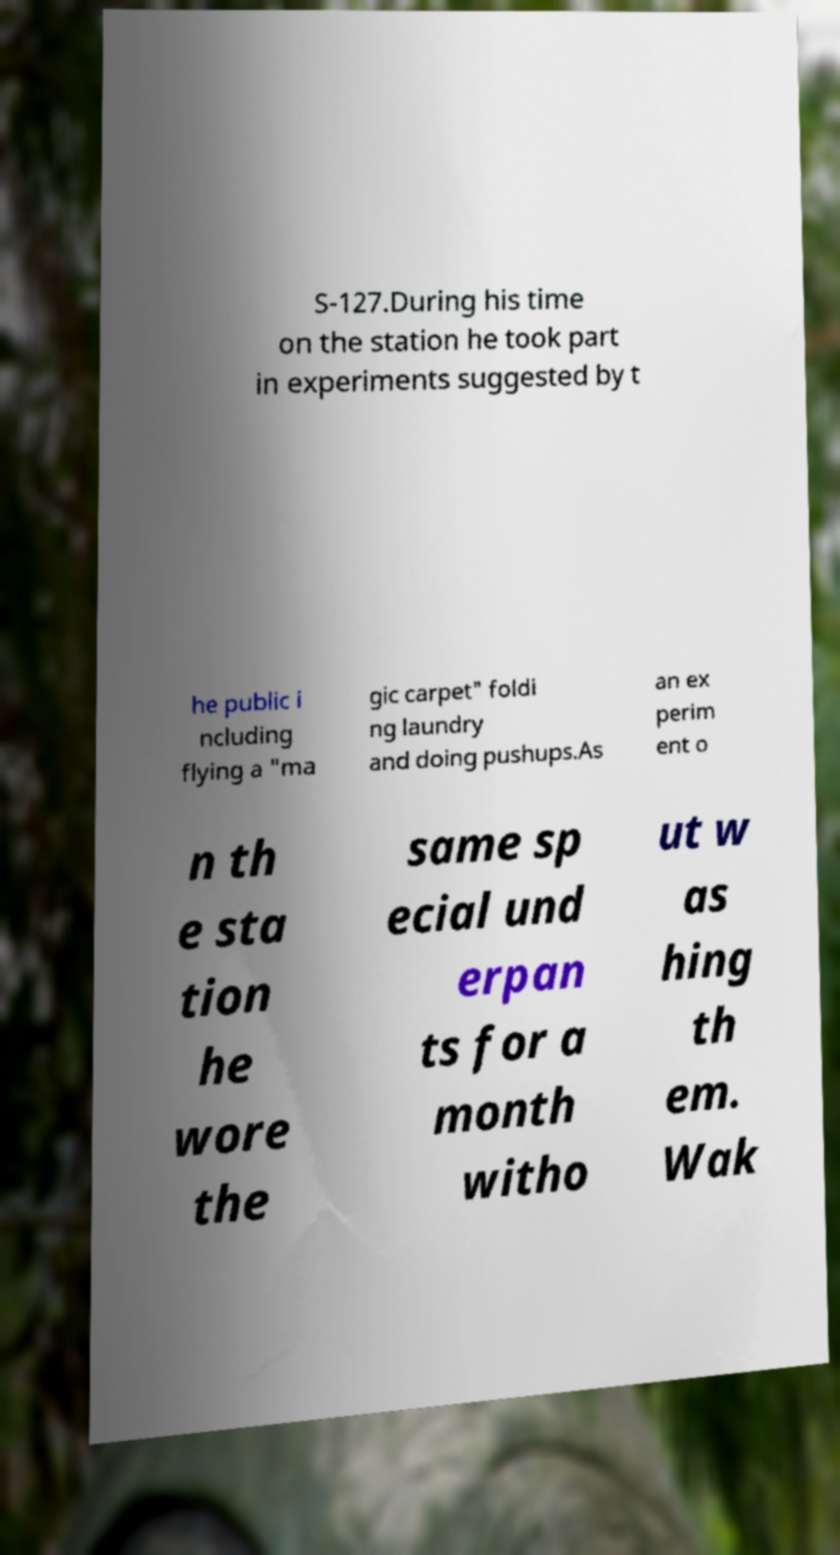Can you read and provide the text displayed in the image?This photo seems to have some interesting text. Can you extract and type it out for me? S-127.During his time on the station he took part in experiments suggested by t he public i ncluding flying a "ma gic carpet" foldi ng laundry and doing pushups.As an ex perim ent o n th e sta tion he wore the same sp ecial und erpan ts for a month witho ut w as hing th em. Wak 